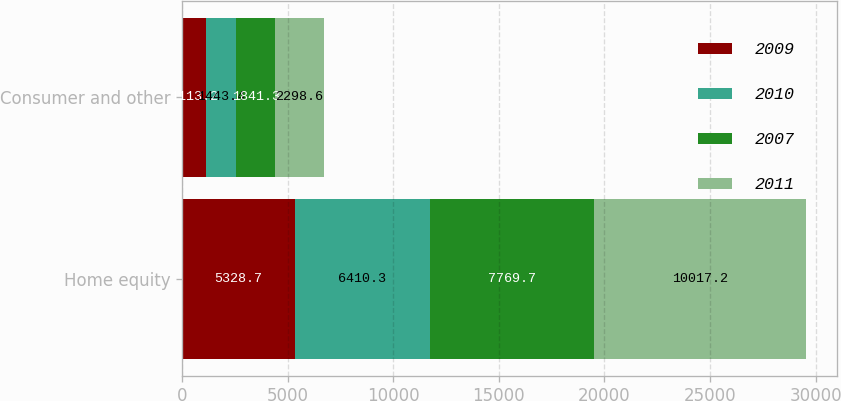Convert chart. <chart><loc_0><loc_0><loc_500><loc_500><stacked_bar_chart><ecel><fcel>Home equity<fcel>Consumer and other<nl><fcel>2009<fcel>5328.7<fcel>1113.2<nl><fcel>2010<fcel>6410.3<fcel>1443.4<nl><fcel>2007<fcel>7769.7<fcel>1841.3<nl><fcel>2011<fcel>10017.2<fcel>2298.6<nl></chart> 